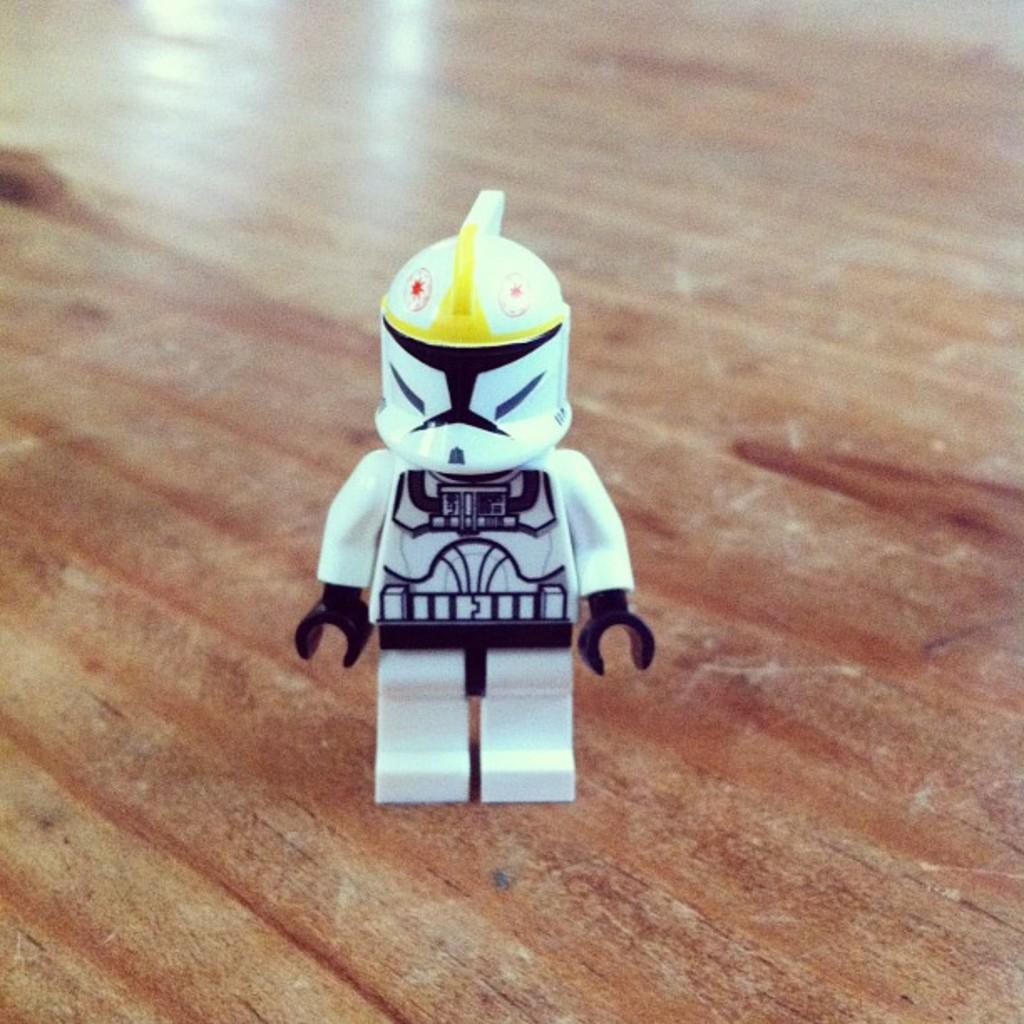What object can be seen in the image? There is a toy in the image. On what surface is the toy placed? The toy is placed on a wooden surface. What type of writing can be seen on the toy in the image? There is no writing visible on the toy in the image. 